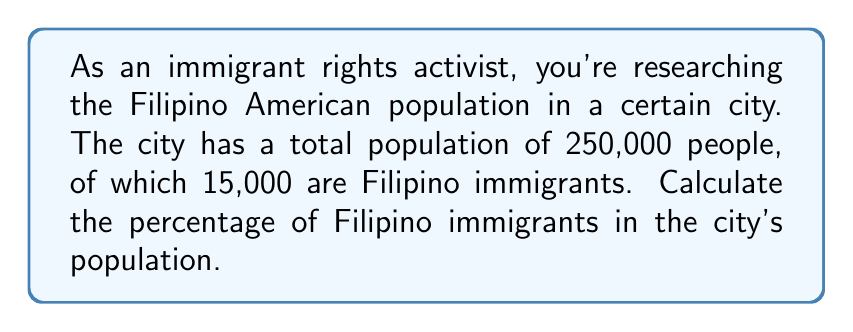Help me with this question. To calculate the percentage of Filipino immigrants in the city's population, we need to use the following formula:

$$ \text{Percentage} = \frac{\text{Part}}{\text{Whole}} \times 100\% $$

Where:
- "Part" is the number of Filipino immigrants
- "Whole" is the total population of the city

Let's plug in the values:

$$ \text{Percentage} = \frac{15,000}{250,000} \times 100\% $$

To simplify this fraction, we can divide both the numerator and denominator by 1,000:

$$ \text{Percentage} = \frac{15}{250} \times 100\% $$

Now, let's perform the division:

$$ \frac{15}{250} = 0.06 $$

Finally, we multiply by 100% to get the percentage:

$$ 0.06 \times 100\% = 6\% $$

Therefore, the percentage of Filipino immigrants in the city's population is 6%.
Answer: 6% 